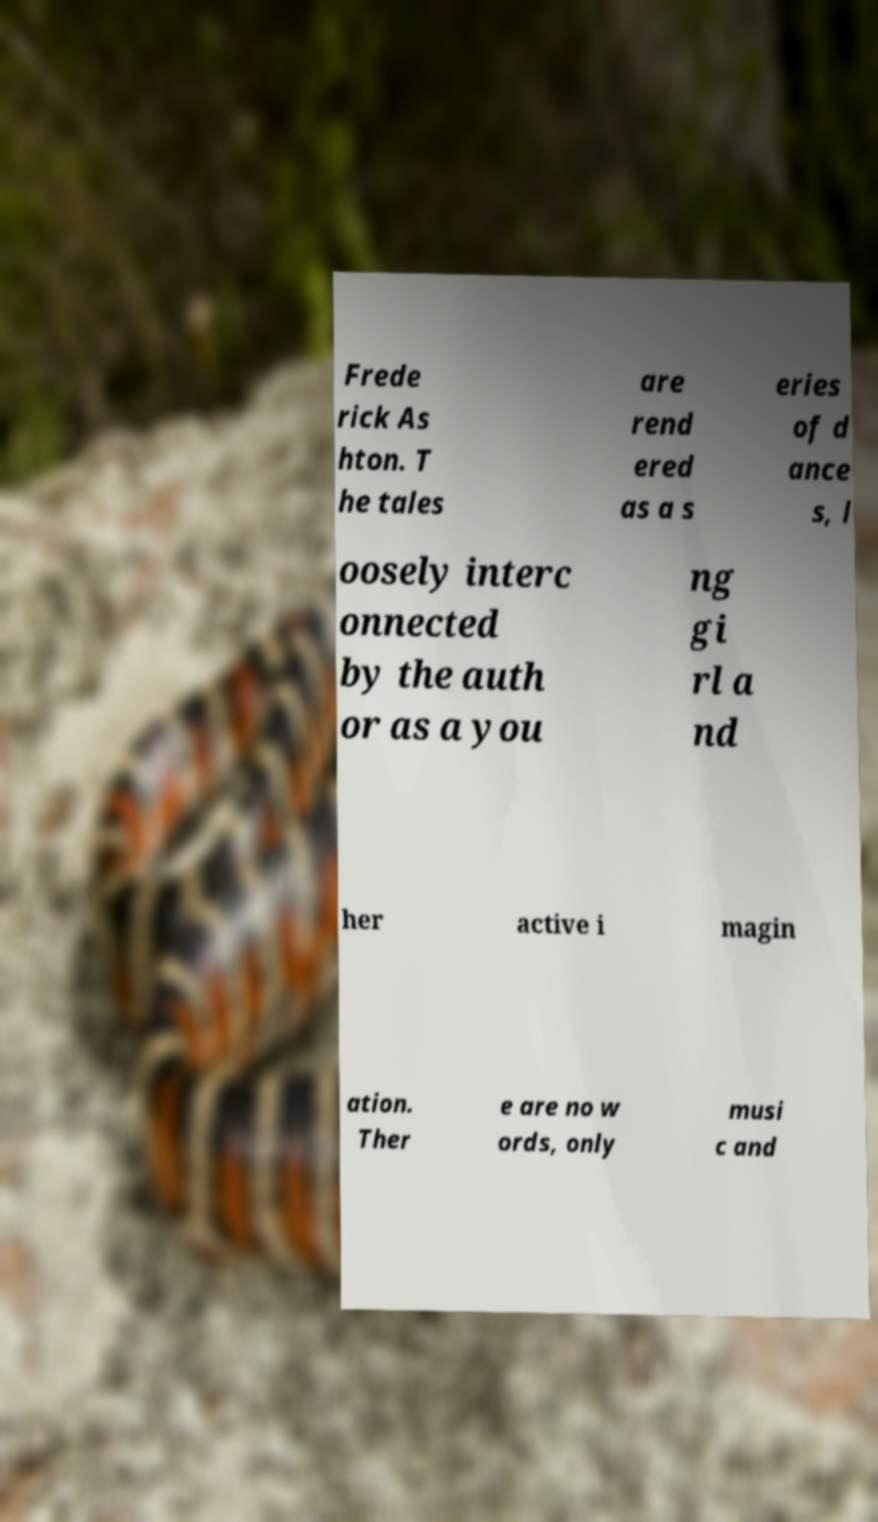Please identify and transcribe the text found in this image. Frede rick As hton. T he tales are rend ered as a s eries of d ance s, l oosely interc onnected by the auth or as a you ng gi rl a nd her active i magin ation. Ther e are no w ords, only musi c and 